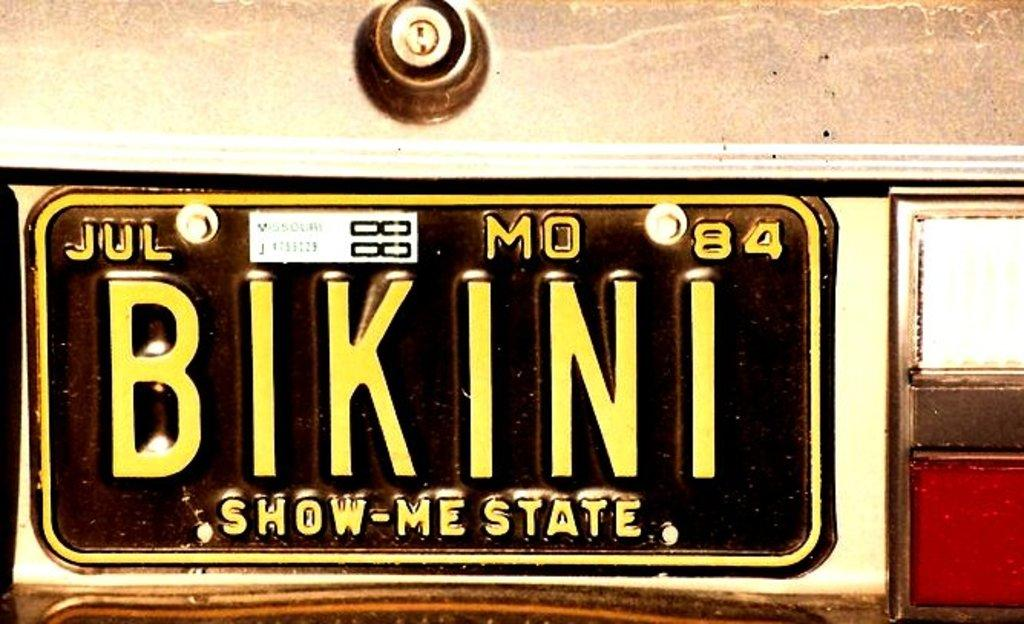Provide a one-sentence caption for the provided image. The vintage car tag from Missouri, the show me state, reads BIKINI. 